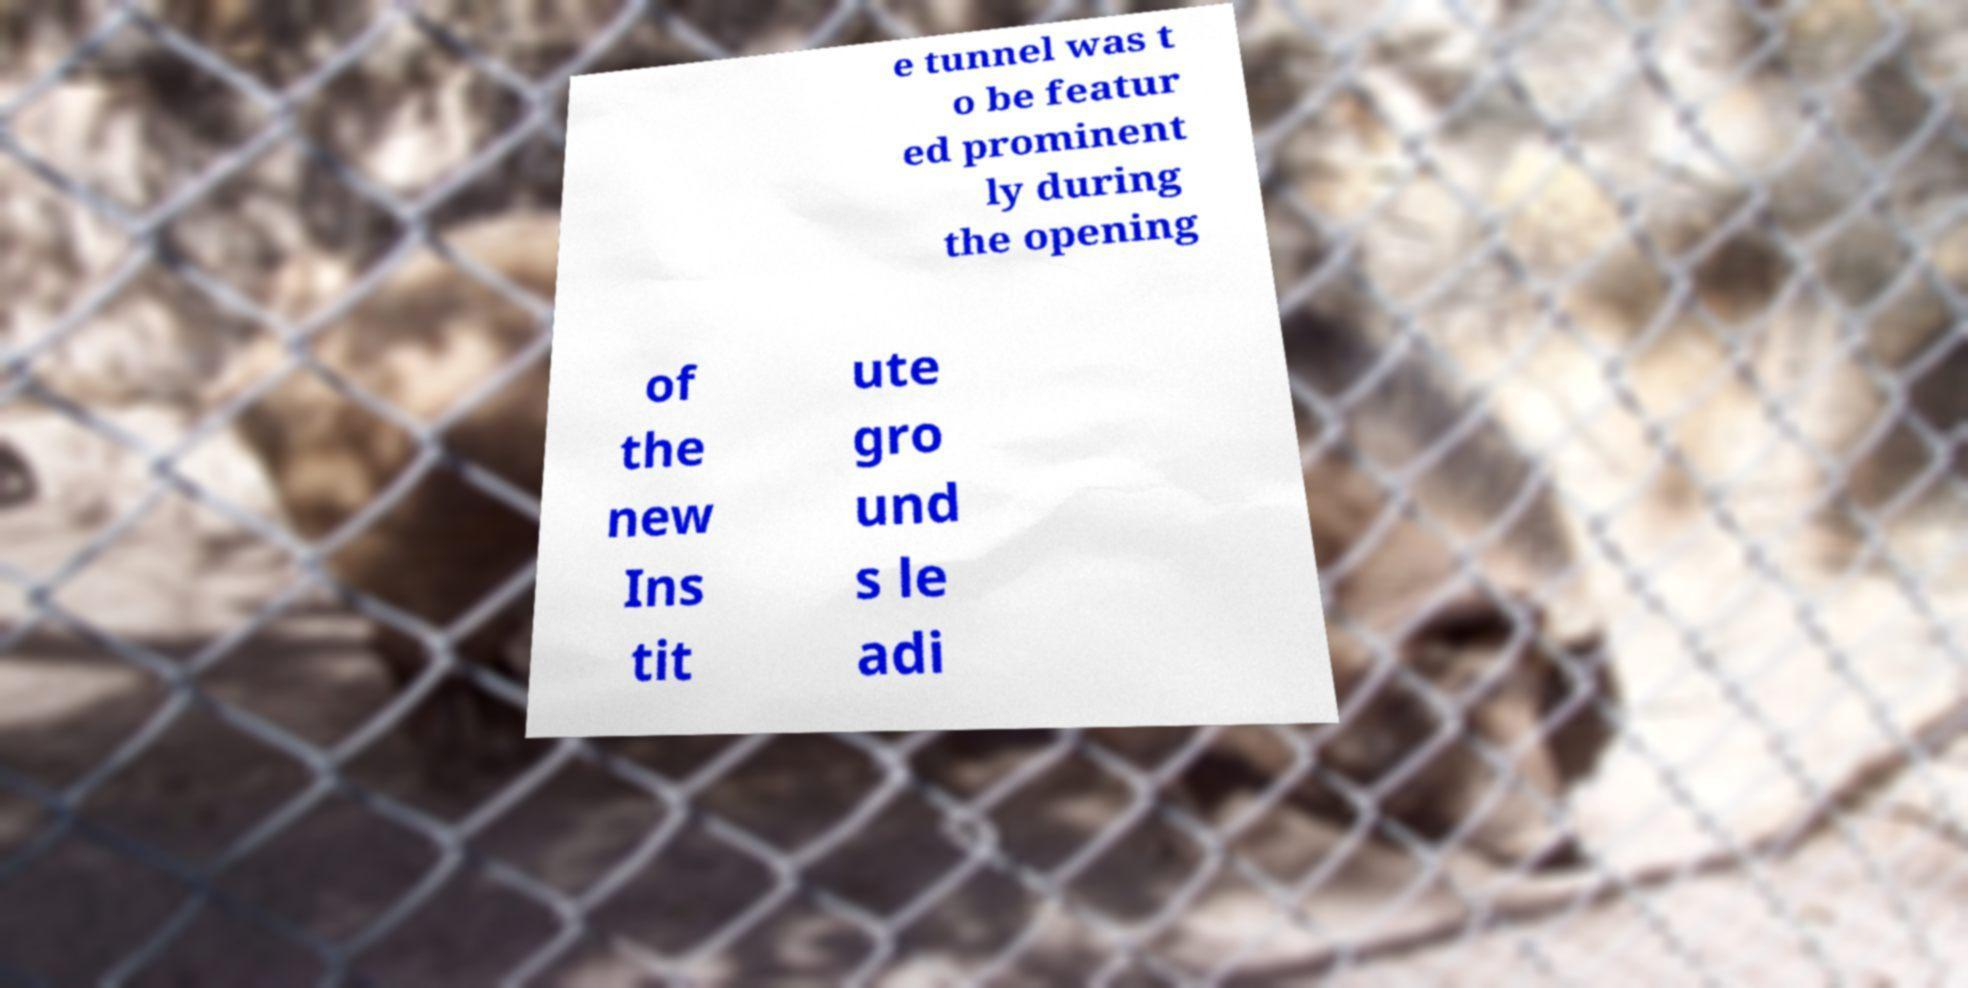For documentation purposes, I need the text within this image transcribed. Could you provide that? e tunnel was t o be featur ed prominent ly during the opening of the new Ins tit ute gro und s le adi 